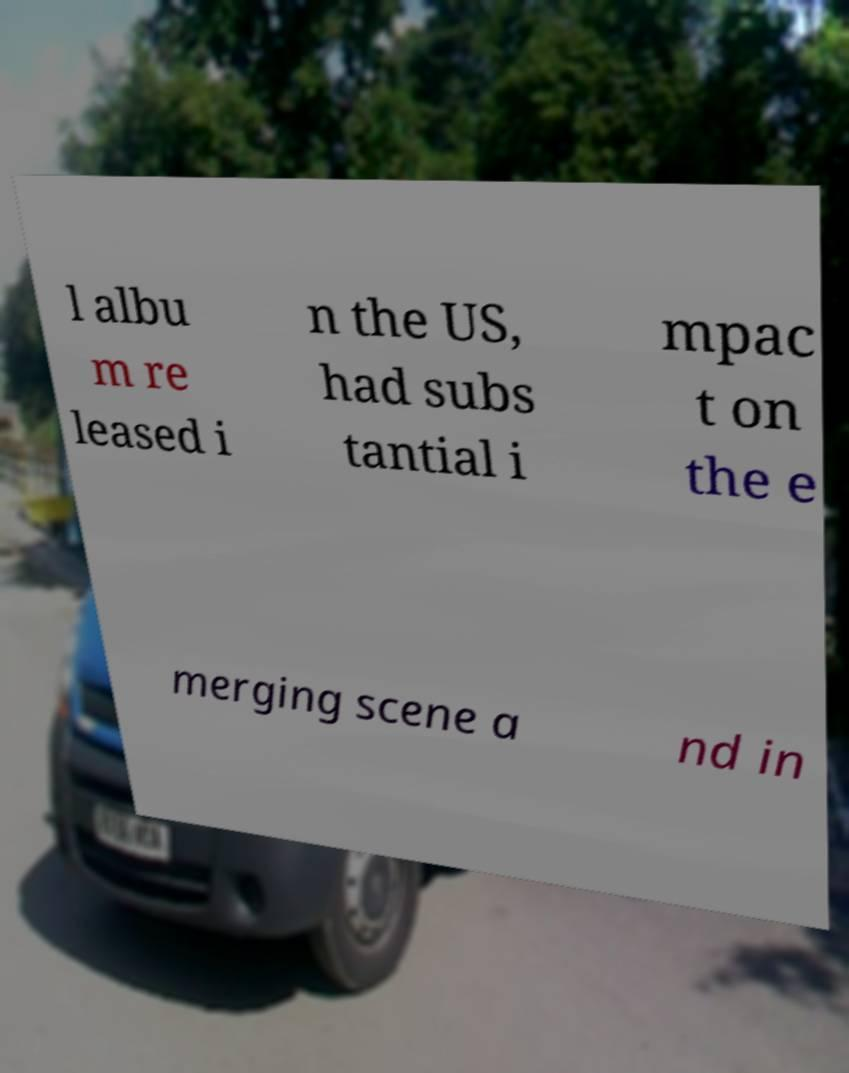Could you assist in decoding the text presented in this image and type it out clearly? l albu m re leased i n the US, had subs tantial i mpac t on the e merging scene a nd in 